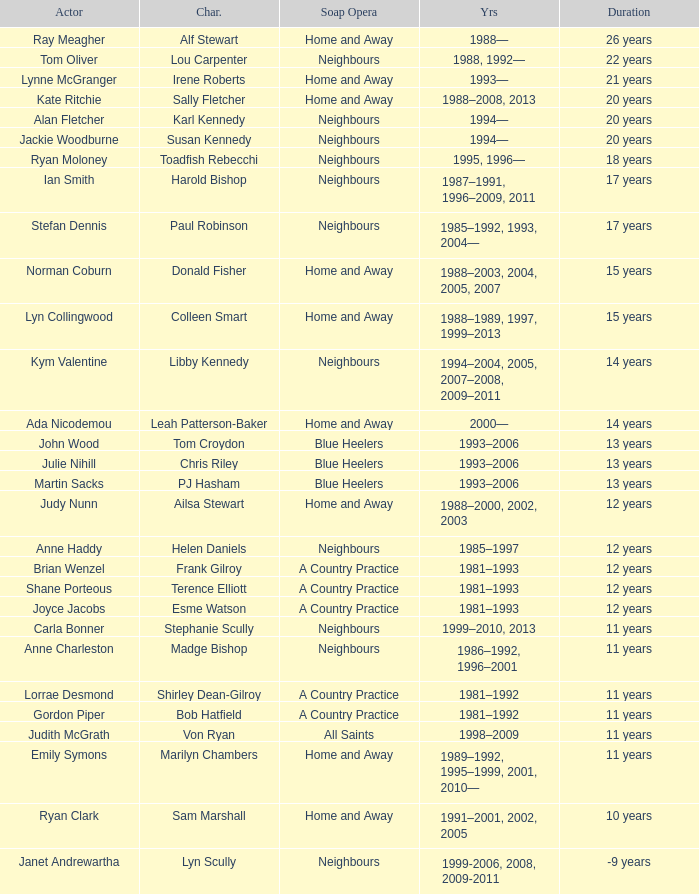What character was portrayed by the same actor for 12 years on Neighbours? Helen Daniels. 